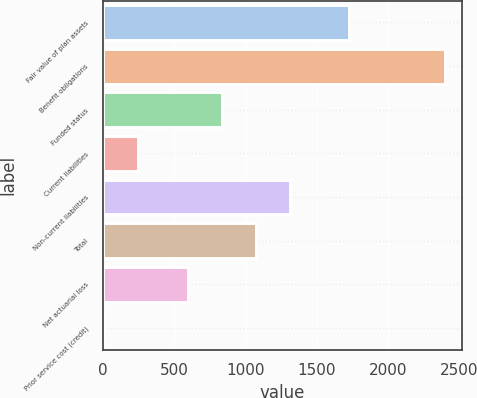Convert chart. <chart><loc_0><loc_0><loc_500><loc_500><bar_chart><fcel>Fair value of plan assets<fcel>Benefit obligations<fcel>Funded status<fcel>Current liabilities<fcel>Non-current liabilities<fcel>Total<fcel>Net actuarial loss<fcel>Prior service cost (credit)<nl><fcel>1727<fcel>2399<fcel>835.1<fcel>247.1<fcel>1313.3<fcel>1074.2<fcel>596<fcel>8<nl></chart> 